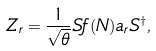<formula> <loc_0><loc_0><loc_500><loc_500>Z _ { r } = \frac { 1 } { \sqrt { \theta } } S f ( N ) a _ { r } S ^ { \dagger } ,</formula> 